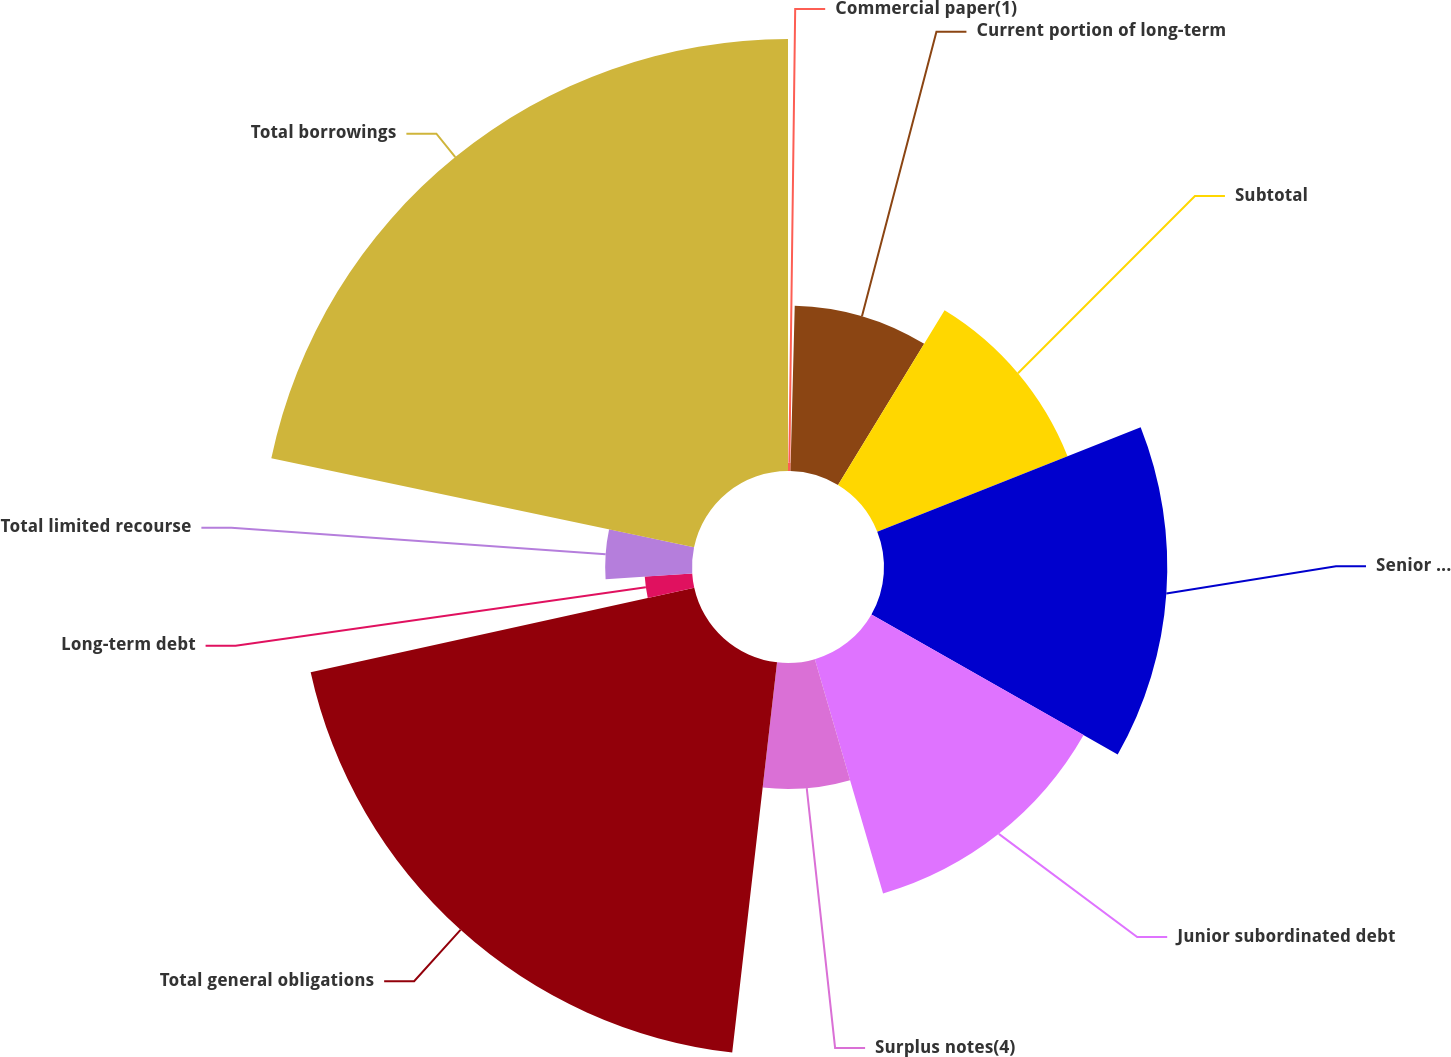Convert chart. <chart><loc_0><loc_0><loc_500><loc_500><pie_chart><fcel>Commercial paper(1)<fcel>Current portion of long-term<fcel>Subtotal<fcel>Senior debt(3)<fcel>Junior subordinated debt<fcel>Surplus notes(4)<fcel>Total general obligations<fcel>Long-term debt<fcel>Total limited recourse<fcel>Total borrowings<nl><fcel>0.41%<fcel>8.31%<fcel>10.28%<fcel>14.23%<fcel>12.26%<fcel>6.33%<fcel>19.73%<fcel>2.39%<fcel>4.36%<fcel>21.7%<nl></chart> 